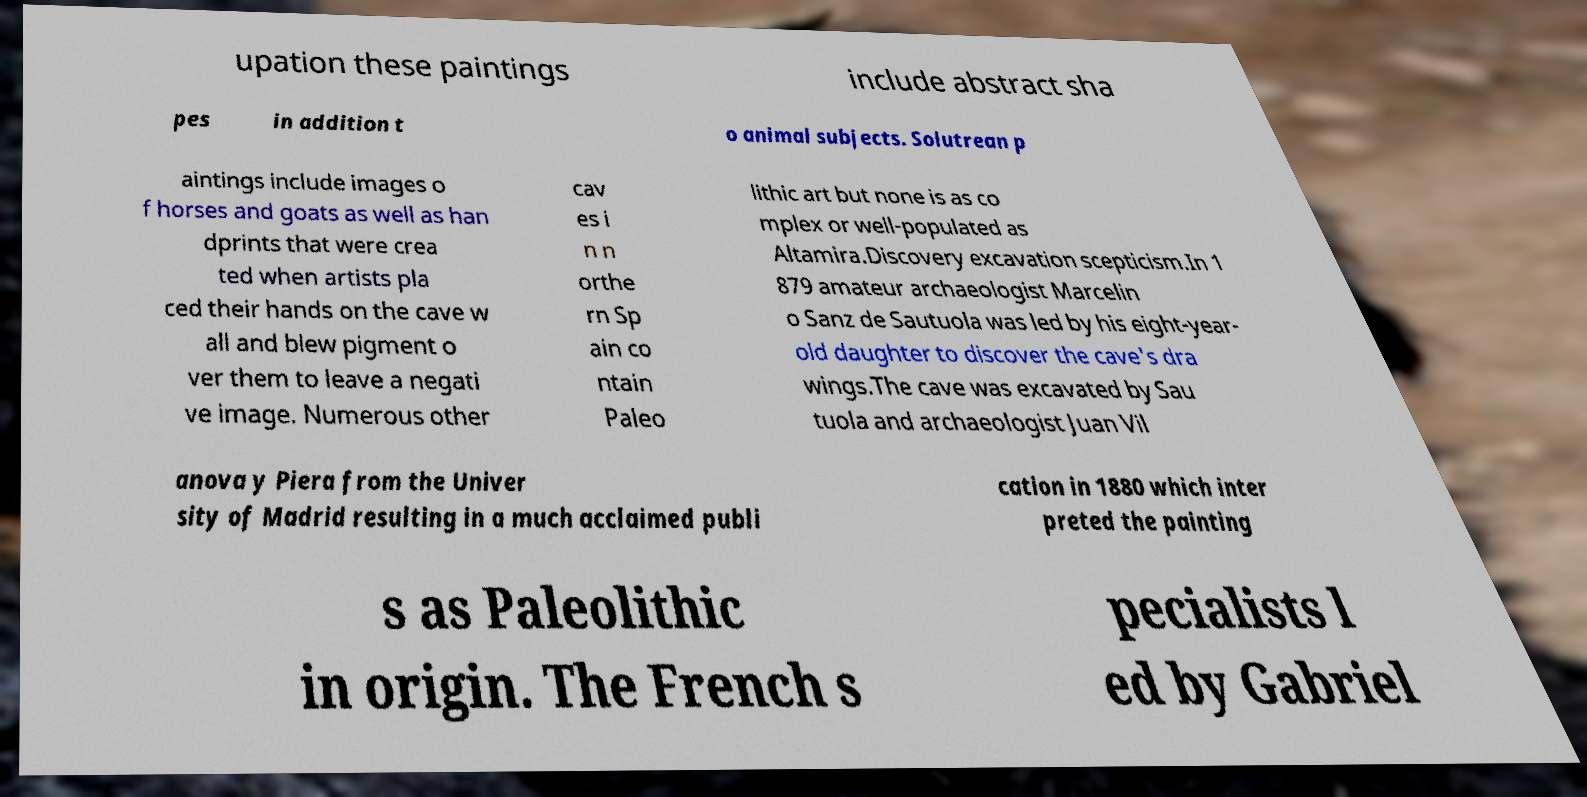Please read and relay the text visible in this image. What does it say? upation these paintings include abstract sha pes in addition t o animal subjects. Solutrean p aintings include images o f horses and goats as well as han dprints that were crea ted when artists pla ced their hands on the cave w all and blew pigment o ver them to leave a negati ve image. Numerous other cav es i n n orthe rn Sp ain co ntain Paleo lithic art but none is as co mplex or well-populated as Altamira.Discovery excavation scepticism.In 1 879 amateur archaeologist Marcelin o Sanz de Sautuola was led by his eight-year- old daughter to discover the cave's dra wings.The cave was excavated by Sau tuola and archaeologist Juan Vil anova y Piera from the Univer sity of Madrid resulting in a much acclaimed publi cation in 1880 which inter preted the painting s as Paleolithic in origin. The French s pecialists l ed by Gabriel 